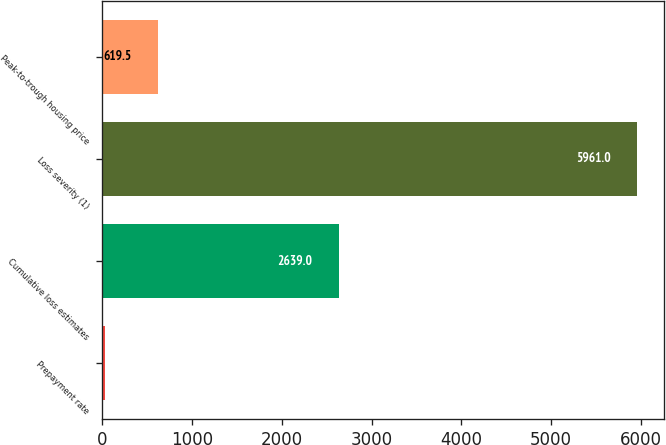Convert chart to OTSL. <chart><loc_0><loc_0><loc_500><loc_500><bar_chart><fcel>Prepayment rate<fcel>Cumulative loss estimates<fcel>Loss severity (1)<fcel>Peak-to-trough housing price<nl><fcel>26<fcel>2639<fcel>5961<fcel>619.5<nl></chart> 